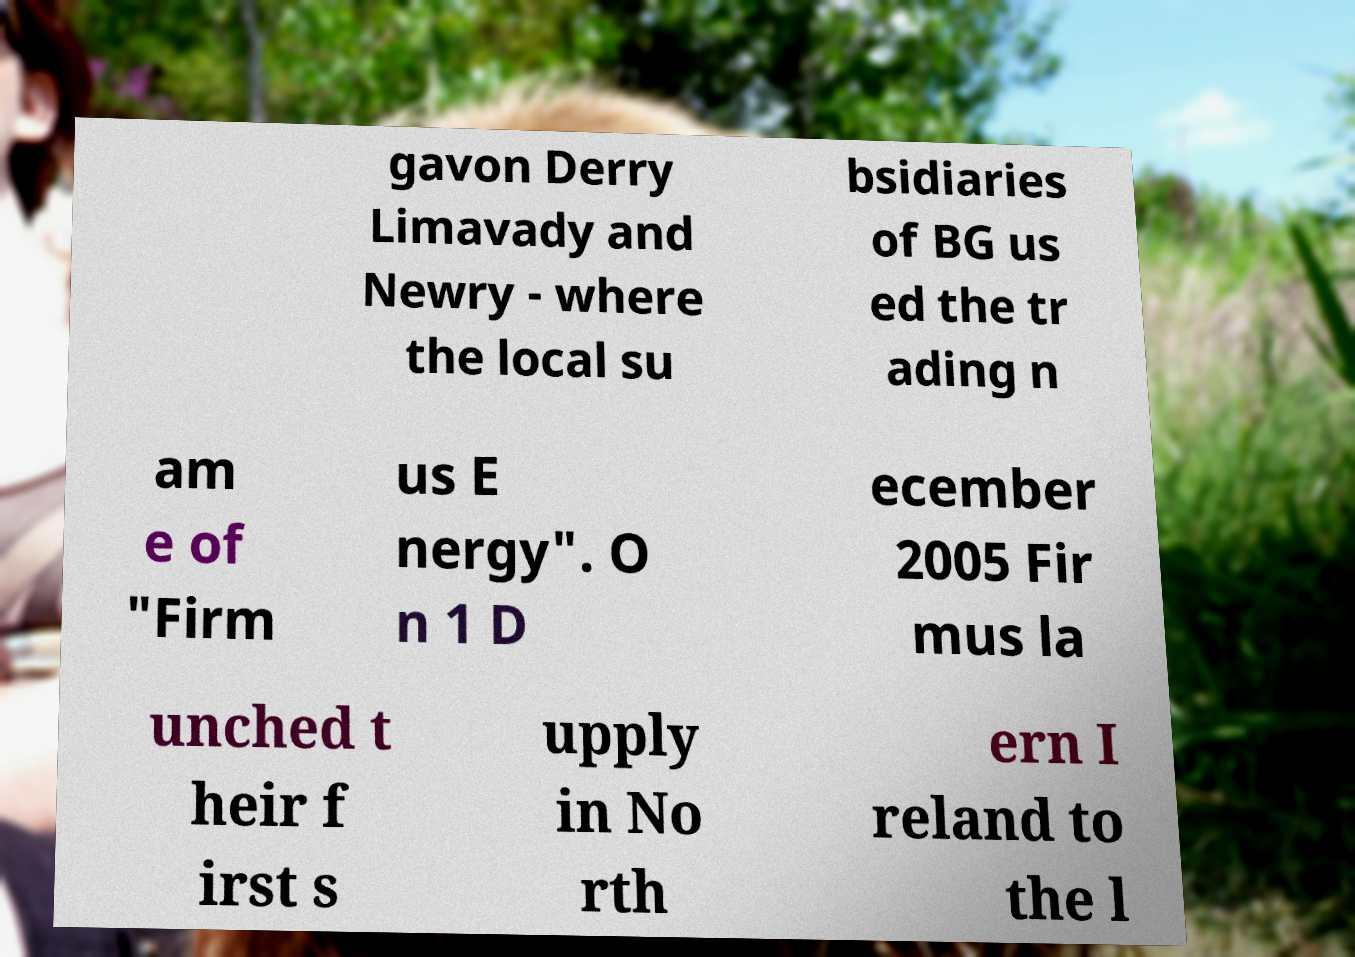Can you accurately transcribe the text from the provided image for me? gavon Derry Limavady and Newry - where the local su bsidiaries of BG us ed the tr ading n am e of "Firm us E nergy". O n 1 D ecember 2005 Fir mus la unched t heir f irst s upply in No rth ern I reland to the l 